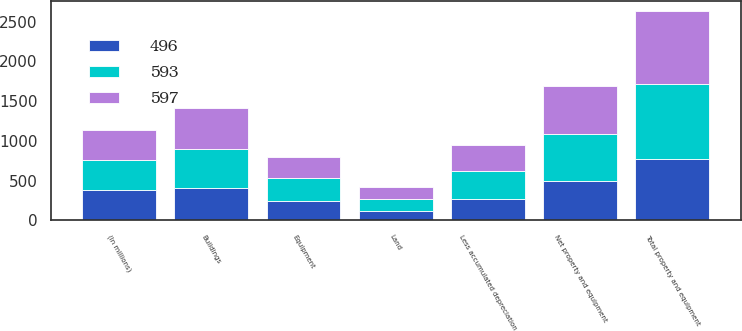<chart> <loc_0><loc_0><loc_500><loc_500><stacked_bar_chart><ecel><fcel>(In millions)<fcel>Land<fcel>Buildings<fcel>Equipment<fcel>Total property and equipment<fcel>Less accumulated depreciation<fcel>Net property and equipment<nl><fcel>593<fcel>378.5<fcel>153<fcel>501<fcel>293<fcel>947<fcel>354<fcel>593<nl><fcel>597<fcel>378.5<fcel>146<fcel>505<fcel>265<fcel>916<fcel>319<fcel>597<nl><fcel>496<fcel>378.5<fcel>120<fcel>403<fcel>244<fcel>767<fcel>271<fcel>496<nl></chart> 